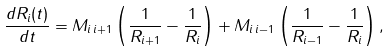Convert formula to latex. <formula><loc_0><loc_0><loc_500><loc_500>\frac { d R _ { i } ( t ) } { d t } = M _ { i \, i + 1 } \left ( \frac { 1 } { R _ { i + 1 } } - \frac { 1 } { R _ { i } } \right ) + M _ { i \, i - 1 } \left ( \frac { 1 } { R _ { i - 1 } } - \frac { 1 } { R _ { i } } \right ) ,</formula> 